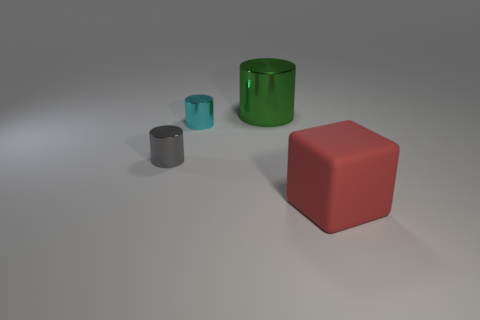Subtract all tiny gray cylinders. How many cylinders are left? 2 Subtract all gray cylinders. How many cylinders are left? 2 Subtract all cubes. How many objects are left? 3 Add 2 red cubes. How many red cubes exist? 3 Add 2 tiny blue matte spheres. How many objects exist? 6 Subtract 1 red blocks. How many objects are left? 3 Subtract all gray blocks. Subtract all yellow balls. How many blocks are left? 1 Subtract all gray blocks. How many gray cylinders are left? 1 Subtract all tiny red metal balls. Subtract all tiny metallic cylinders. How many objects are left? 2 Add 2 matte things. How many matte things are left? 3 